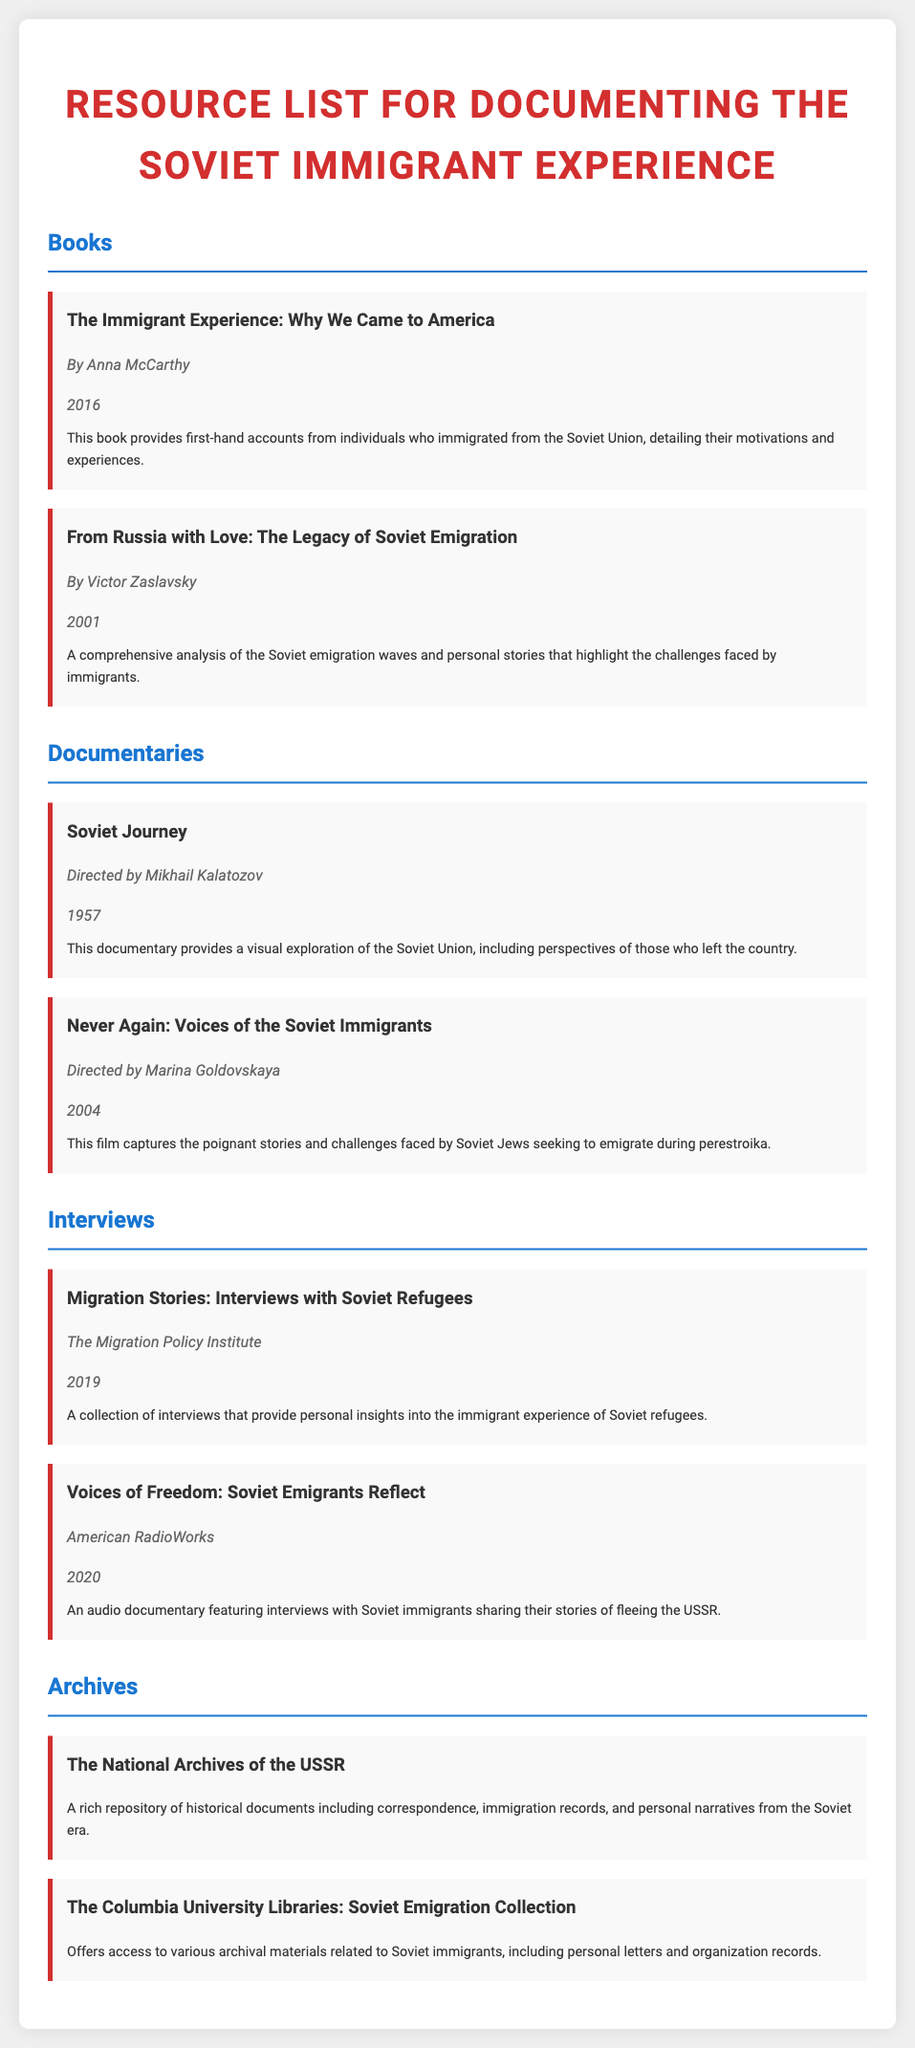What is the title of the book by Anna McCarthy? The document provides the title of the book authored by Anna McCarthy, which is listed in the Books section.
Answer: The Immigrant Experience: Why We Came to America Who directed the documentary "Never Again: Voices of the Soviet Immigrants"? The document indicates that Marina Goldovskaya is the director of this particular documentary.
Answer: Marina Goldovskaya In what year was the book "From Russia with Love: The Legacy of Soviet Emigration" published? The document states the publication year of Victor Zaslavsky's book in the Books section.
Answer: 2001 What type of resource is "Voices of Freedom: Soviet Emigrants Reflect"? The document categorizes this resource under interviews, indicating its nature.
Answer: Interview What is one of the resources related to Soviet emigration available at Columbia University Libraries? The document lists the archives and indicates that the Columbia University Libraries holds a specific collection relevant to Soviet immigrants.
Answer: The Columbia University Libraries: Soviet Emigration Collection What year was the documentary "Soviet Journey" released? The document specifies the release year of the documentary, which is found in the Documentaries section.
Answer: 1957 What collection provides insights from Soviet refugees? The document mentions a specific collection of interviews that offers personal insights into the experiences of Soviet refugees.
Answer: Migration Stories: Interviews with Soviet Refugees What is the purpose of the "National Archives of the USSR"? The document describes the purpose of this archive concerning the historical records from the Soviet era.
Answer: A rich repository of historical documents 